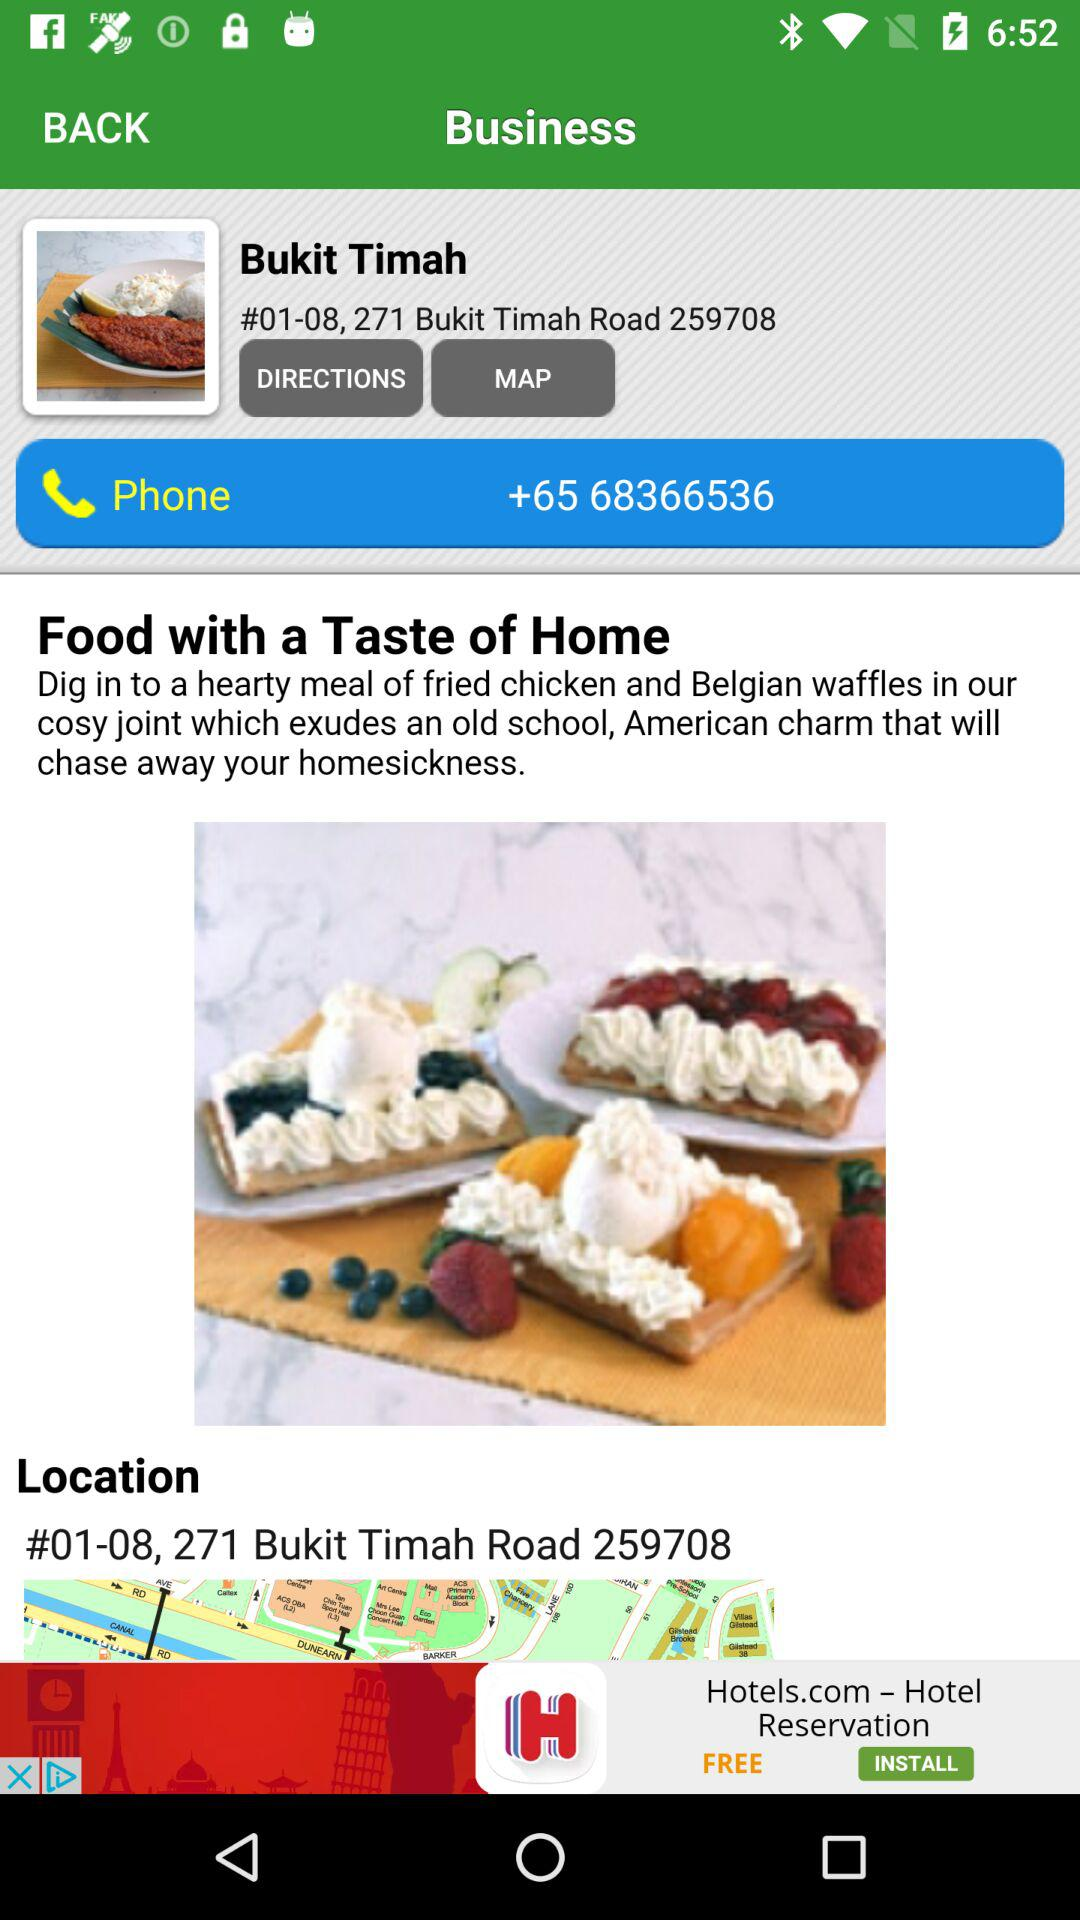What is the phone number? The phone number is +65 68366536. 